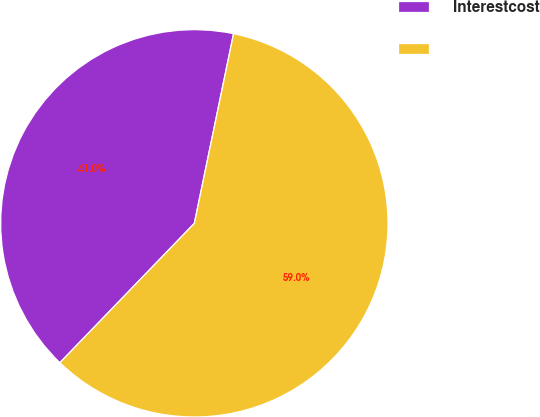Convert chart to OTSL. <chart><loc_0><loc_0><loc_500><loc_500><pie_chart><fcel>Interestcost<fcel>Unnamed: 1<nl><fcel>41.03%<fcel>58.97%<nl></chart> 